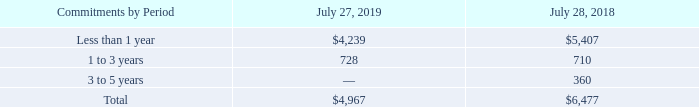(b) Purchase Commitments with Contract Manufacturers and Suppliers
We purchase components from a variety of suppliers and use several contract manufacturers to provide manufacturing services for our products. During the normal course of business, in order to manage manufacturing lead times and help ensure adequate component supply, we enter into agreements with contract manufacturers and suppliers that either allow them to procure inventory based upon criteria as defined by us or establish the parameters defining our requirements. A significant portion of our reported purchase commitments arising from these agreements consists of firm, noncancelable, and unconditional commitments. Certain of these purchase commitments with contract manufacturers and suppliers relate to arrangements to secure long-term pricing for certain product components for multi-year periods. In certain instances, these agreements allow us the option to cancel, reschedule, and adjust our requirements based on our business needs prior to firm orders being placed.
The following table summarizes our purchase commitments with contract manufacturers and suppliers (in millions):
We record a liability for firm, noncancelable, and unconditional purchase commitments for quantities in excess of our future demand forecasts consistent with the valuation of our excess and obsolete inventory. As of July 27, 2019 and July 28, 2018, the liability for these purchase commitments was $129 million and $159 million, respectively, and was included in other current liabilities.
How does the company provide manufacturing services for their products? Purchase components from a variety of suppliers and use several contract manufacturers. What were the purchase commitments with commitments that were 1 to 3 years in 2019?
Answer scale should be: million. 728. What were the purchase commitments with commitments that were 3 to 5 years in 2018?
Answer scale should be: million. 360. What was the percentage change in total purchase commitments between 2018 and 2019?
Answer scale should be: percent. (4,967-6,477)/6,477
Answer: -23.31. How many years did total purchase commitments exceed $5,000 million? 2018
Answer: 1. What was the change in the amount of purchase commitments for commitments that were less than 1 year between 2018 and 2019?
Answer scale should be: million. 4,239-5,407
Answer: -1168. 